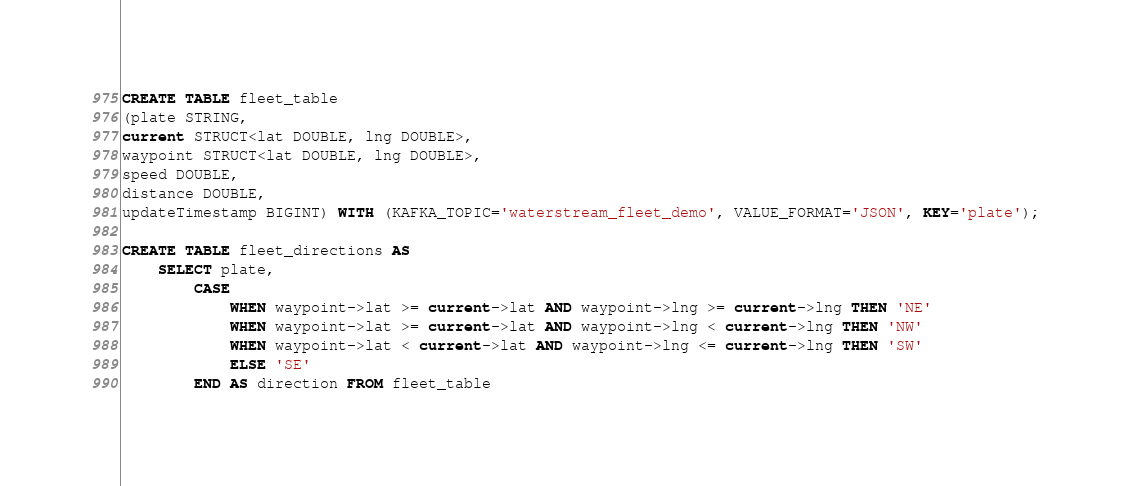<code> <loc_0><loc_0><loc_500><loc_500><_SQL_>CREATE TABLE fleet_table
(plate STRING,
current STRUCT<lat DOUBLE, lng DOUBLE>,
waypoint STRUCT<lat DOUBLE, lng DOUBLE>,
speed DOUBLE,
distance DOUBLE,
updateTimestamp BIGINT) WITH (KAFKA_TOPIC='waterstream_fleet_demo', VALUE_FORMAT='JSON', KEY='plate');

CREATE TABLE fleet_directions AS
    SELECT plate,
        CASE
            WHEN waypoint->lat >= current->lat AND waypoint->lng >= current->lng THEN 'NE'
            WHEN waypoint->lat >= current->lat AND waypoint->lng < current->lng THEN 'NW'
            WHEN waypoint->lat < current->lat AND waypoint->lng <= current->lng THEN 'SW'
            ELSE 'SE'
        END AS direction FROM fleet_table</code> 